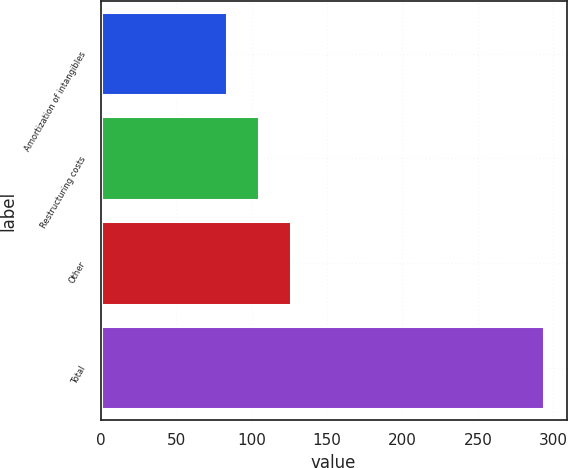Convert chart. <chart><loc_0><loc_0><loc_500><loc_500><bar_chart><fcel>Amortization of intangibles<fcel>Restructuring costs<fcel>Other<fcel>Total<nl><fcel>84<fcel>105<fcel>126<fcel>294<nl></chart> 